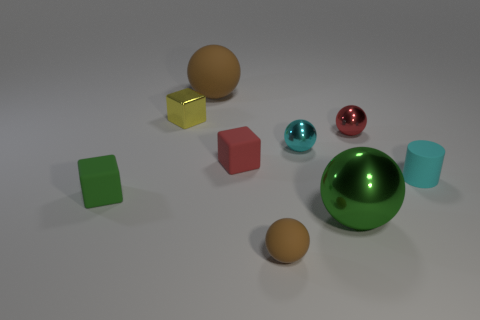What shape is the tiny cyan thing that is on the right side of the big thing that is in front of the rubber object right of the tiny cyan shiny object?
Provide a short and direct response. Cylinder. What number of tiny brown matte things are in front of the large thing that is in front of the red metallic sphere?
Offer a terse response. 1. Are the small green thing and the small cyan sphere made of the same material?
Your answer should be very brief. No. What number of cubes are on the left side of the yellow cube that is left of the brown rubber object that is in front of the yellow cube?
Give a very brief answer. 1. What is the color of the small metallic object that is on the right side of the cyan sphere?
Provide a succinct answer. Red. What is the shape of the metal thing left of the brown rubber thing to the left of the small brown thing?
Offer a very short reply. Cube. Is the color of the big rubber sphere the same as the small matte sphere?
Give a very brief answer. Yes. What number of cubes are either cyan rubber things or small green objects?
Your response must be concise. 1. The thing that is right of the green sphere and behind the red block is made of what material?
Your answer should be very brief. Metal. There is a large brown thing; how many large things are right of it?
Provide a short and direct response. 1. 